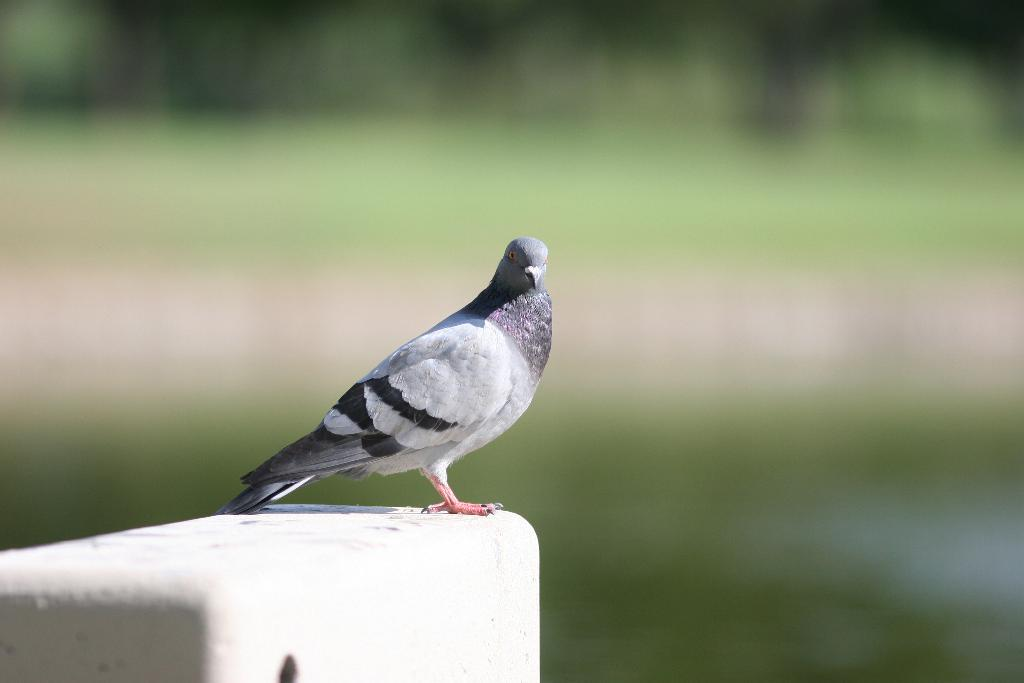What type of animal is in the image? There is a pigeon in the image. Where is the pigeon located? The pigeon is on a wall. How many sisters are present in the image? There are no sisters present in the image; it features a pigeon on a wall. What type of basin can be seen in the image? There is no basin present in the image. 